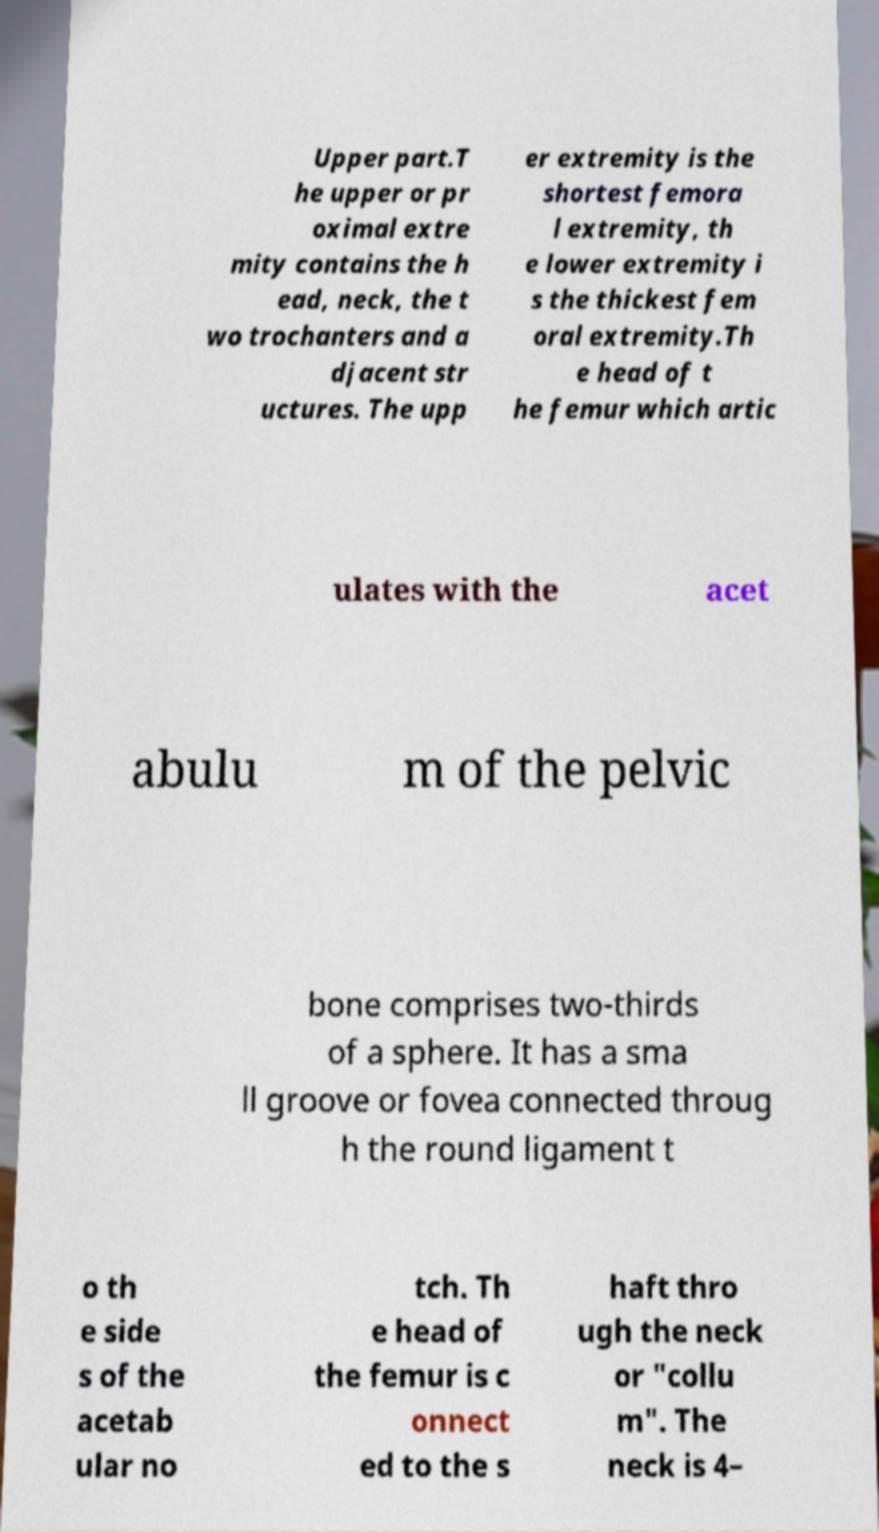Could you assist in decoding the text presented in this image and type it out clearly? Upper part.T he upper or pr oximal extre mity contains the h ead, neck, the t wo trochanters and a djacent str uctures. The upp er extremity is the shortest femora l extremity, th e lower extremity i s the thickest fem oral extremity.Th e head of t he femur which artic ulates with the acet abulu m of the pelvic bone comprises two-thirds of a sphere. It has a sma ll groove or fovea connected throug h the round ligament t o th e side s of the acetab ular no tch. Th e head of the femur is c onnect ed to the s haft thro ugh the neck or "collu m". The neck is 4– 